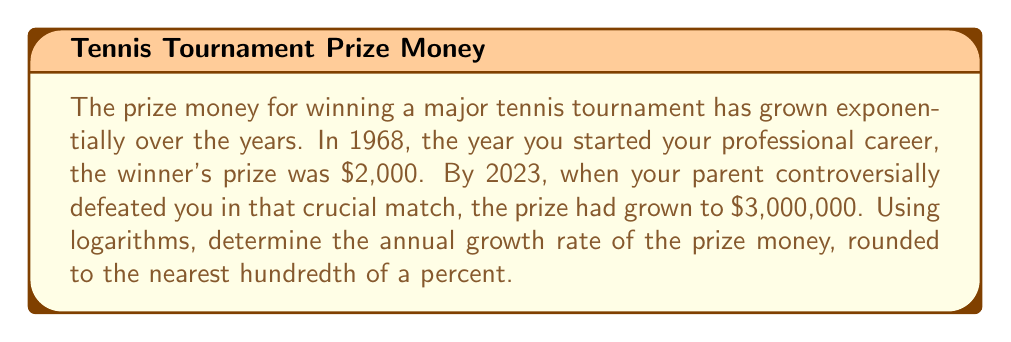Could you help me with this problem? Let's approach this step-by-step using the exponential growth formula and logarithms:

1) The exponential growth formula is:
   $$A = P(1 + r)^t$$
   where A is the final amount, P is the initial amount, r is the annual growth rate, and t is the time in years.

2) We have:
   P = $2,000 (initial prize in 1968)
   A = $3,000,000 (final prize in 2023)
   t = 2023 - 1968 = 55 years

3) Substituting these values:
   $$3,000,000 = 2,000(1 + r)^{55}$$

4) Divide both sides by 2,000:
   $$1,500 = (1 + r)^{55}$$

5) Take the natural logarithm of both sides:
   $$\ln(1,500) = 55 \ln(1 + r)$$

6) Divide both sides by 55:
   $$\frac{\ln(1,500)}{55} = \ln(1 + r)$$

7) Take e to the power of both sides:
   $$e^{\frac{\ln(1,500)}{55}} = e^{\ln(1 + r)} = 1 + r$$

8) Subtract 1 from both sides:
   $$e^{\frac{\ln(1,500)}{55}} - 1 = r$$

9) Calculate:
   $$r \approx 0.1333 = 13.33\%$$

10) Rounding to the nearest hundredth of a percent:
    $$r \approx 13.33\%$$
Answer: 13.33% 